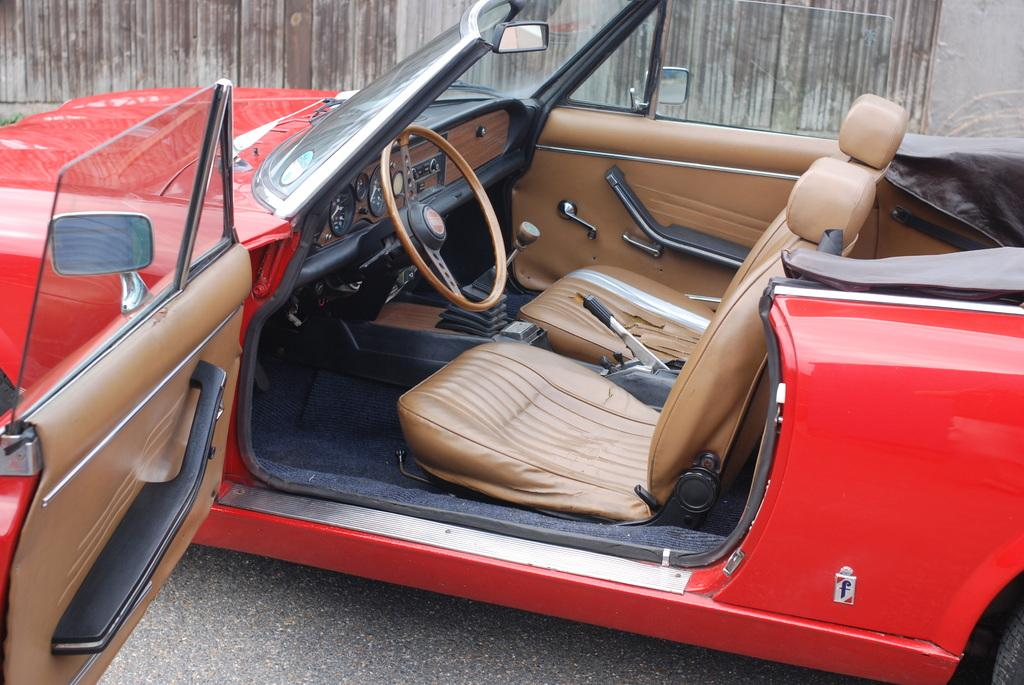What is the main subject of the image? The main subject of the image is a car. What feature is present inside the car? The car has a steering wheel. What type of material can be seen in the background of the image? There is a wooden wall in the background of the image. What type of beef is being served on the desk in the image? There is no beef or desk present in the image; it features a car with a steering wheel and a wooden wall in the background. 